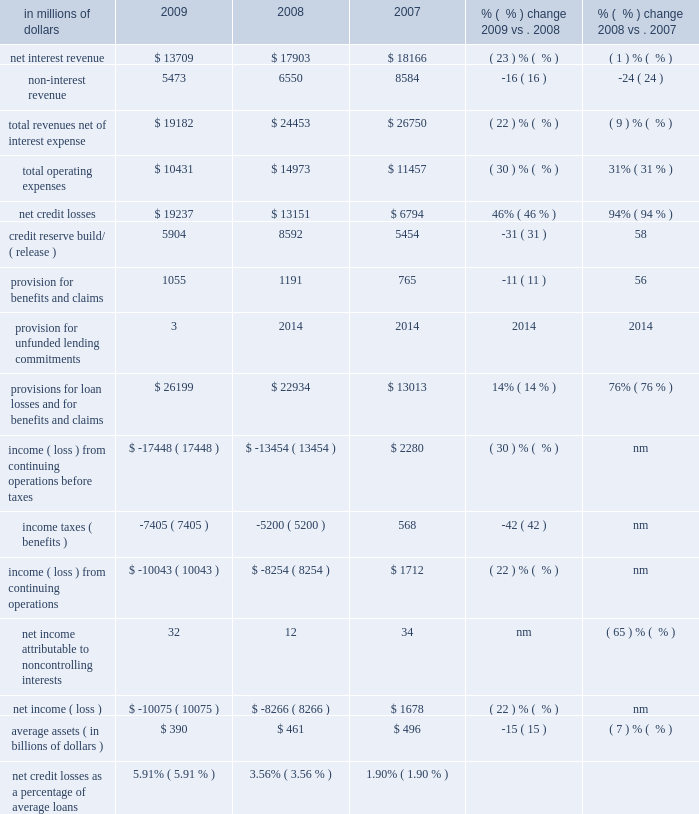Local consumer lending local consumer lending ( lcl ) , which constituted approximately 65% ( 65 % ) of citi holdings by assets as of december 31 , 2009 , includes a portion of citigroup 2019s north american mortgage business , retail partner cards , western european cards and retail banking , citifinancial north america , primerica , student loan corporation and other local consumer finance businesses globally .
At december 31 , 2009 , lcl had $ 358 billion of assets ( $ 317 billion in north america ) .
About one-half of the assets in lcl as of december 31 , 2009 consisted of u.s .
Mortgages in the company 2019s citimortgage and citifinancial operations .
The north american assets consist of residential mortgage loans , retail partner card loans , student loans , personal loans , auto loans , commercial real estate , and other consumer loans and assets .
In millions of dollars 2009 2008 2007 % (  % ) change 2009 vs .
2008 % (  % ) change 2008 vs .
2007 .
Nm not meaningful 2009 vs .
2008 revenues , net of interest expense decreased 22% ( 22 % ) versus the prior year , mostly due to lower net interest revenue .
Net interest revenue was 23% ( 23 % ) lower than the prior year , primarily due to lower balances , de-risking of the portfolio , and spread compression .
Net interest revenue as a percentage of average loans decreased 63 basis points from the prior year , primarily due to the impact of higher delinquencies , interest write-offs , loan modification programs , higher fdic charges and card act implementation ( in the latter part of 2009 ) , partially offset by retail partner cards pricing actions .
Lcl results will continue to be impacted by the card act .
Citi currently estimates that the net impact on lcl revenues for 2010 could be a reduction of approximately $ 50 to $ 150 million .
See also 201cnorth america regional consumer banking 201d and 201cmanaging global risk 2014credit risk 201d for additional information on the impact of the card act to citi 2019s credit card businesses .
Average loans decreased 12% ( 12 % ) , with north america down 11% ( 11 % ) and international down 19% ( 19 % ) .
Non-interest revenue decreased $ 1.1 billion mostly driven by the impact of higher credit losses flowing through the securitization trusts .
Operating expenses declined 30% ( 30 % ) from the prior year , due to lower volumes and reductions from expense re-engineering actions , and the impact of goodwill write-offs of $ 3.0 billion in the fourth quarter of 2008 , partially offset by higher other real estate owned and collection costs .
Provisions for loan losses and for benefits and claims increased 14% ( 14 % ) versus the prior year reflecting an increase in net credit losses of $ 6.1 billion , partially offset by lower reserve builds of $ 2.7 billion .
Higher net credit losses were primarily driven by higher losses of $ 3.6 billion in residential real estate lending , $ 1.0 billion in retail partner cards , and $ 0.7 billion in international .
Assets decreased $ 58 billion versus the prior year , primarily driven by lower originations , wind-down of specific businesses , asset sales , divestitures , write-offs and higher loan loss reserve balances .
Key divestitures in 2009 included the fi credit card business , italy consumer finance , diners europe , portugal cards , norway consumer , and diners club north america .
2008 vs .
2007 revenues , net of interest expense decreased 9% ( 9 % ) versus the prior year , mostly due to lower non-interest revenue .
Net interest revenue declined 1% ( 1 % ) versus the prior year .
Average loans increased 3% ( 3 % ) ; however , revenues declined , driven by lower balances , de-risking of the portfolio , and spread compression .
Non-interest revenue decreased $ 2 billion , primarily due to the impact of securitization in retail partners cards and the mark-to-market on the mortgage servicing rights asset and related hedge in real estate lending .
Operating expenses increased 31% ( 31 % ) , driven by the impact of goodwill write-offs of $ 3.0 billion in the fourth quarter of 2008 and restructuring costs .
Excluding one-time expenses , expenses were slightly higher due to increased volumes. .
What percent of total revenues net of interest expense was non-interest revenue in 2009? 
Computations: (5473 / 19182)
Answer: 0.28532. 